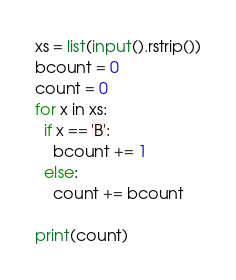Convert code to text. <code><loc_0><loc_0><loc_500><loc_500><_Python_>xs = list(input().rstrip())
bcount = 0
count = 0
for x in xs:
  if x == 'B':
    bcount += 1
  else:
    count += bcount

print(count)
</code> 